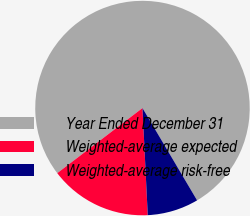Convert chart to OTSL. <chart><loc_0><loc_0><loc_500><loc_500><pie_chart><fcel>Year Ended December 31<fcel>Weighted-average expected<fcel>Weighted-average risk-free<nl><fcel>76.88%<fcel>15.4%<fcel>7.72%<nl></chart> 